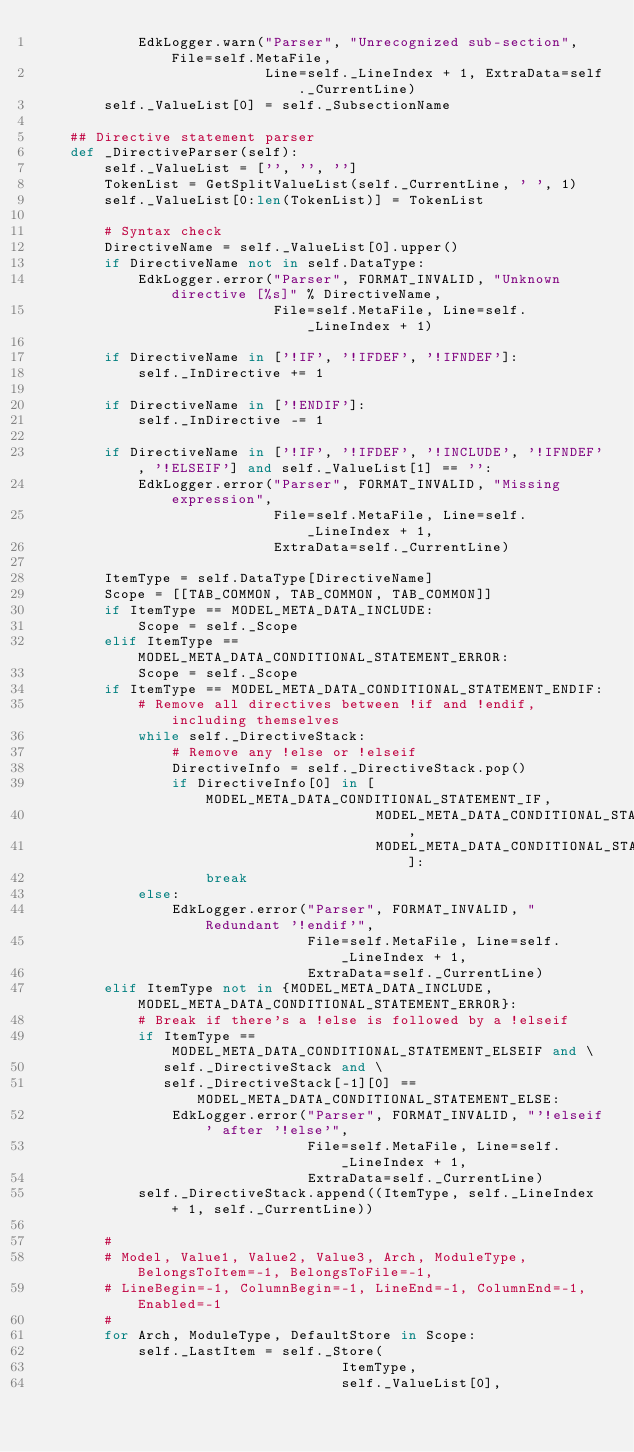Convert code to text. <code><loc_0><loc_0><loc_500><loc_500><_Python_>            EdkLogger.warn("Parser", "Unrecognized sub-section", File=self.MetaFile,
                           Line=self._LineIndex + 1, ExtraData=self._CurrentLine)
        self._ValueList[0] = self._SubsectionName

    ## Directive statement parser
    def _DirectiveParser(self):
        self._ValueList = ['', '', '']
        TokenList = GetSplitValueList(self._CurrentLine, ' ', 1)
        self._ValueList[0:len(TokenList)] = TokenList

        # Syntax check
        DirectiveName = self._ValueList[0].upper()
        if DirectiveName not in self.DataType:
            EdkLogger.error("Parser", FORMAT_INVALID, "Unknown directive [%s]" % DirectiveName,
                            File=self.MetaFile, Line=self._LineIndex + 1)

        if DirectiveName in ['!IF', '!IFDEF', '!IFNDEF']:
            self._InDirective += 1

        if DirectiveName in ['!ENDIF']:
            self._InDirective -= 1

        if DirectiveName in ['!IF', '!IFDEF', '!INCLUDE', '!IFNDEF', '!ELSEIF'] and self._ValueList[1] == '':
            EdkLogger.error("Parser", FORMAT_INVALID, "Missing expression",
                            File=self.MetaFile, Line=self._LineIndex + 1,
                            ExtraData=self._CurrentLine)

        ItemType = self.DataType[DirectiveName]
        Scope = [[TAB_COMMON, TAB_COMMON, TAB_COMMON]]
        if ItemType == MODEL_META_DATA_INCLUDE:
            Scope = self._Scope
        elif ItemType == MODEL_META_DATA_CONDITIONAL_STATEMENT_ERROR:
            Scope = self._Scope
        if ItemType == MODEL_META_DATA_CONDITIONAL_STATEMENT_ENDIF:
            # Remove all directives between !if and !endif, including themselves
            while self._DirectiveStack:
                # Remove any !else or !elseif
                DirectiveInfo = self._DirectiveStack.pop()
                if DirectiveInfo[0] in [MODEL_META_DATA_CONDITIONAL_STATEMENT_IF,
                                        MODEL_META_DATA_CONDITIONAL_STATEMENT_IFDEF,
                                        MODEL_META_DATA_CONDITIONAL_STATEMENT_IFNDEF]:
                    break
            else:
                EdkLogger.error("Parser", FORMAT_INVALID, "Redundant '!endif'",
                                File=self.MetaFile, Line=self._LineIndex + 1,
                                ExtraData=self._CurrentLine)
        elif ItemType not in {MODEL_META_DATA_INCLUDE, MODEL_META_DATA_CONDITIONAL_STATEMENT_ERROR}:
            # Break if there's a !else is followed by a !elseif
            if ItemType == MODEL_META_DATA_CONDITIONAL_STATEMENT_ELSEIF and \
               self._DirectiveStack and \
               self._DirectiveStack[-1][0] == MODEL_META_DATA_CONDITIONAL_STATEMENT_ELSE:
                EdkLogger.error("Parser", FORMAT_INVALID, "'!elseif' after '!else'",
                                File=self.MetaFile, Line=self._LineIndex + 1,
                                ExtraData=self._CurrentLine)
            self._DirectiveStack.append((ItemType, self._LineIndex + 1, self._CurrentLine))

        #
        # Model, Value1, Value2, Value3, Arch, ModuleType, BelongsToItem=-1, BelongsToFile=-1,
        # LineBegin=-1, ColumnBegin=-1, LineEnd=-1, ColumnEnd=-1, Enabled=-1
        #
        for Arch, ModuleType, DefaultStore in Scope:
            self._LastItem = self._Store(
                                    ItemType,
                                    self._ValueList[0],</code> 